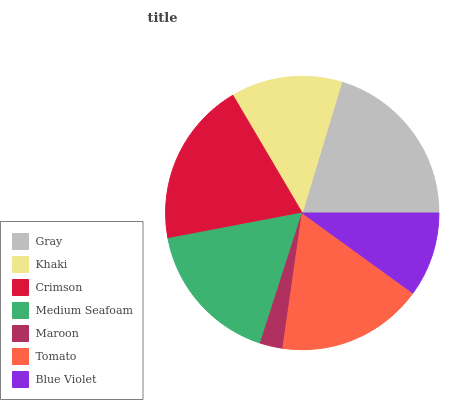Is Maroon the minimum?
Answer yes or no. Yes. Is Gray the maximum?
Answer yes or no. Yes. Is Khaki the minimum?
Answer yes or no. No. Is Khaki the maximum?
Answer yes or no. No. Is Gray greater than Khaki?
Answer yes or no. Yes. Is Khaki less than Gray?
Answer yes or no. Yes. Is Khaki greater than Gray?
Answer yes or no. No. Is Gray less than Khaki?
Answer yes or no. No. Is Medium Seafoam the high median?
Answer yes or no. Yes. Is Medium Seafoam the low median?
Answer yes or no. Yes. Is Gray the high median?
Answer yes or no. No. Is Gray the low median?
Answer yes or no. No. 